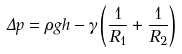<formula> <loc_0><loc_0><loc_500><loc_500>\Delta p = \rho g h - \gamma \left ( { \frac { 1 } { R _ { 1 } } } + { \frac { 1 } { R _ { 2 } } } \right )</formula> 